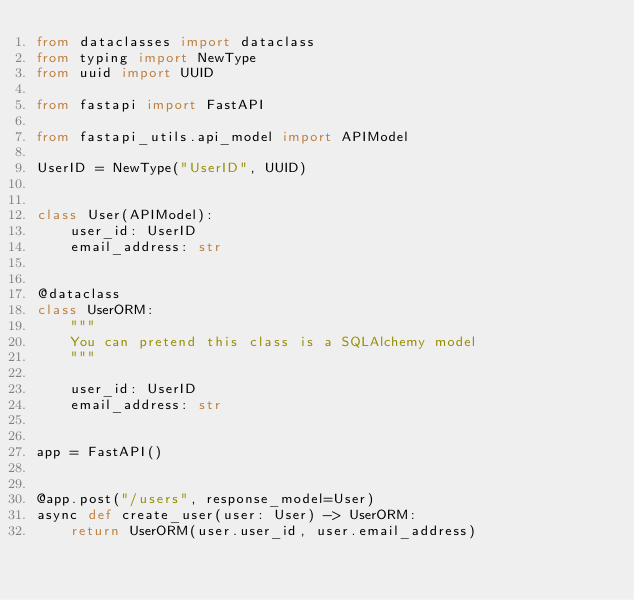Convert code to text. <code><loc_0><loc_0><loc_500><loc_500><_Python_>from dataclasses import dataclass
from typing import NewType
from uuid import UUID

from fastapi import FastAPI

from fastapi_utils.api_model import APIModel

UserID = NewType("UserID", UUID)


class User(APIModel):
    user_id: UserID
    email_address: str


@dataclass
class UserORM:
    """
    You can pretend this class is a SQLAlchemy model
    """

    user_id: UserID
    email_address: str


app = FastAPI()


@app.post("/users", response_model=User)
async def create_user(user: User) -> UserORM:
    return UserORM(user.user_id, user.email_address)
</code> 